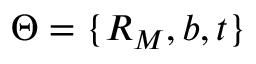Convert formula to latex. <formula><loc_0><loc_0><loc_500><loc_500>\Theta = \{ R _ { M } , b , t \}</formula> 